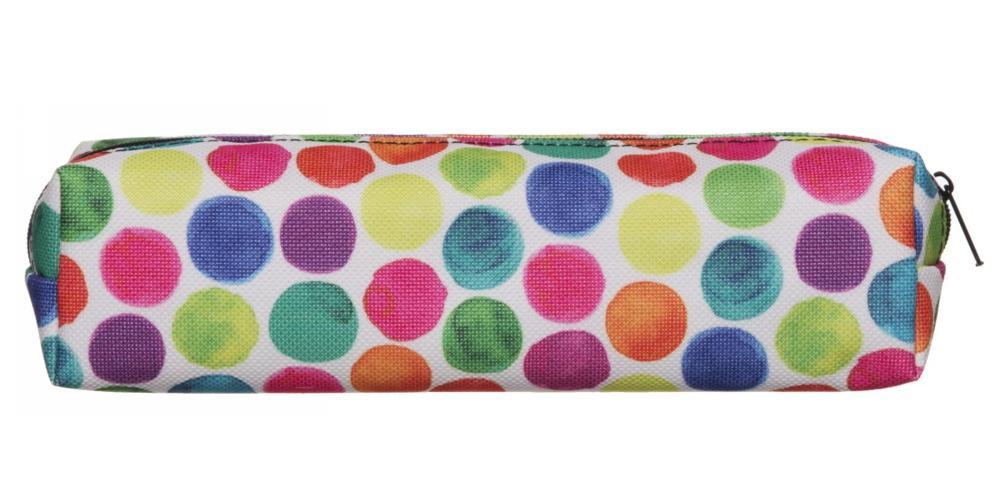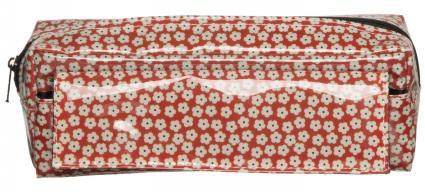The first image is the image on the left, the second image is the image on the right. Given the left and right images, does the statement "There is a bag with a multi-colored polka dot pattern on it." hold true? Answer yes or no. Yes. 